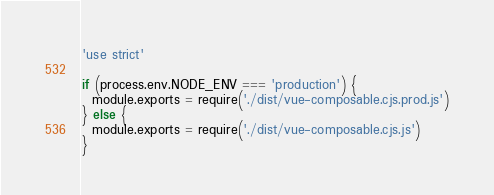Convert code to text. <code><loc_0><loc_0><loc_500><loc_500><_JavaScript_>'use strict'

if (process.env.NODE_ENV === 'production') {
  module.exports = require('./dist/vue-composable.cjs.prod.js')
} else {
  module.exports = require('./dist/vue-composable.cjs.js')
}
</code> 